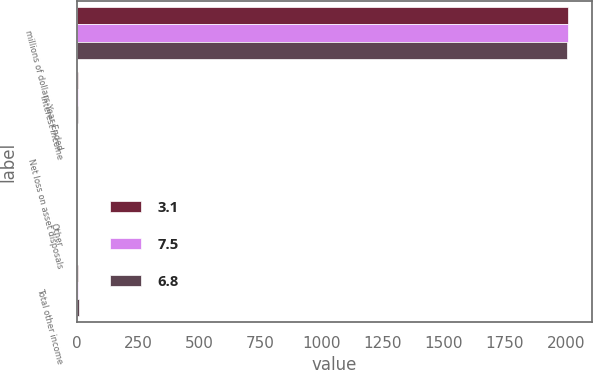Convert chart to OTSL. <chart><loc_0><loc_0><loc_500><loc_500><stacked_bar_chart><ecel><fcel>millions of dollars Year Ended<fcel>Interest income<fcel>Net loss on asset disposals<fcel>Other<fcel>Total other income<nl><fcel>3.1<fcel>2008<fcel>7.1<fcel>2<fcel>0.2<fcel>3.1<nl><fcel>7.5<fcel>2007<fcel>6.7<fcel>0.6<fcel>0.7<fcel>6.8<nl><fcel>6.8<fcel>2006<fcel>3.2<fcel>1<fcel>0.5<fcel>7.5<nl></chart> 